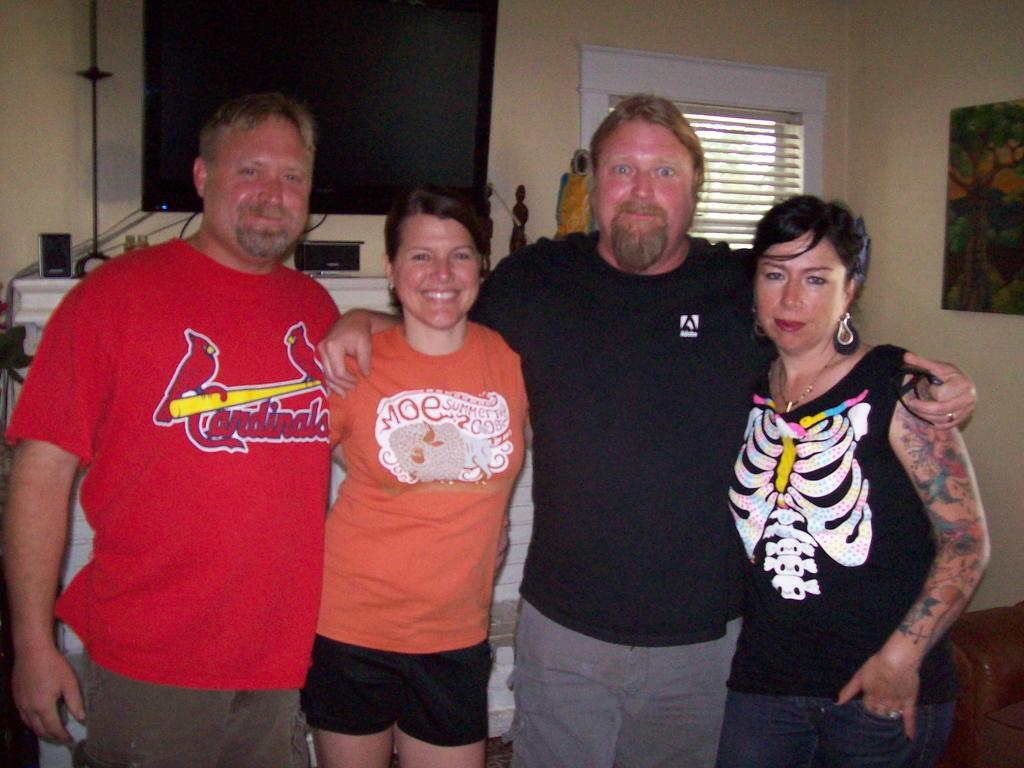<image>
Share a concise interpretation of the image provided. a Cardinals shirt that is on a man 